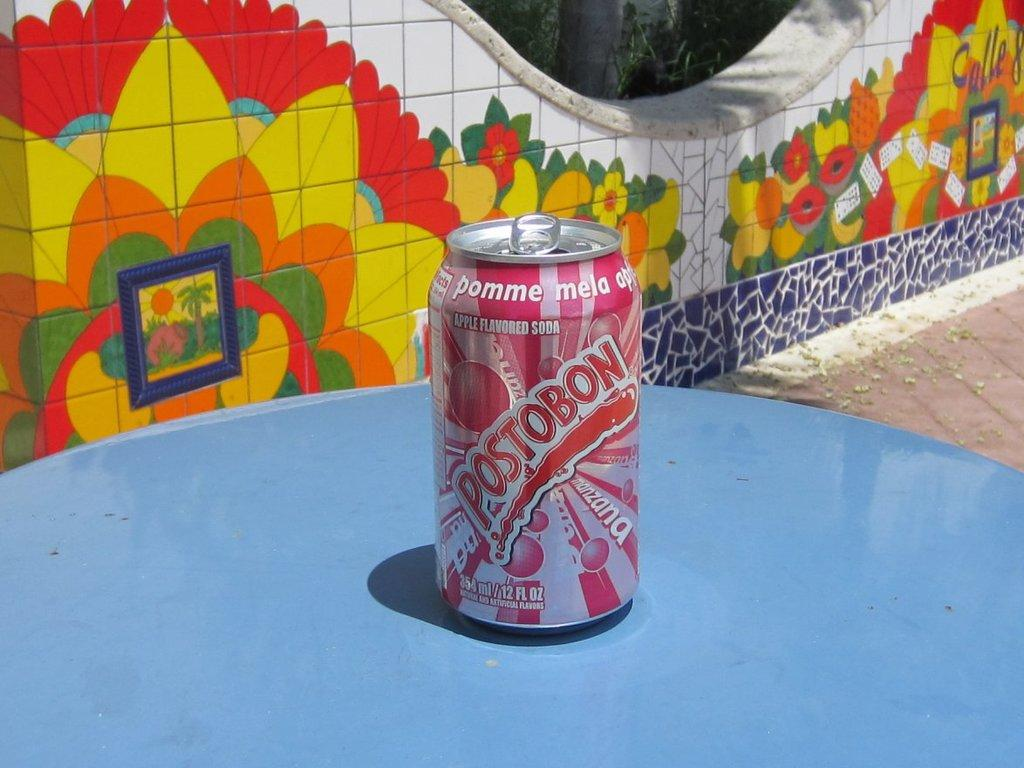Provide a one-sentence caption for the provided image. A can of postobon soda sitting on a blue table. 